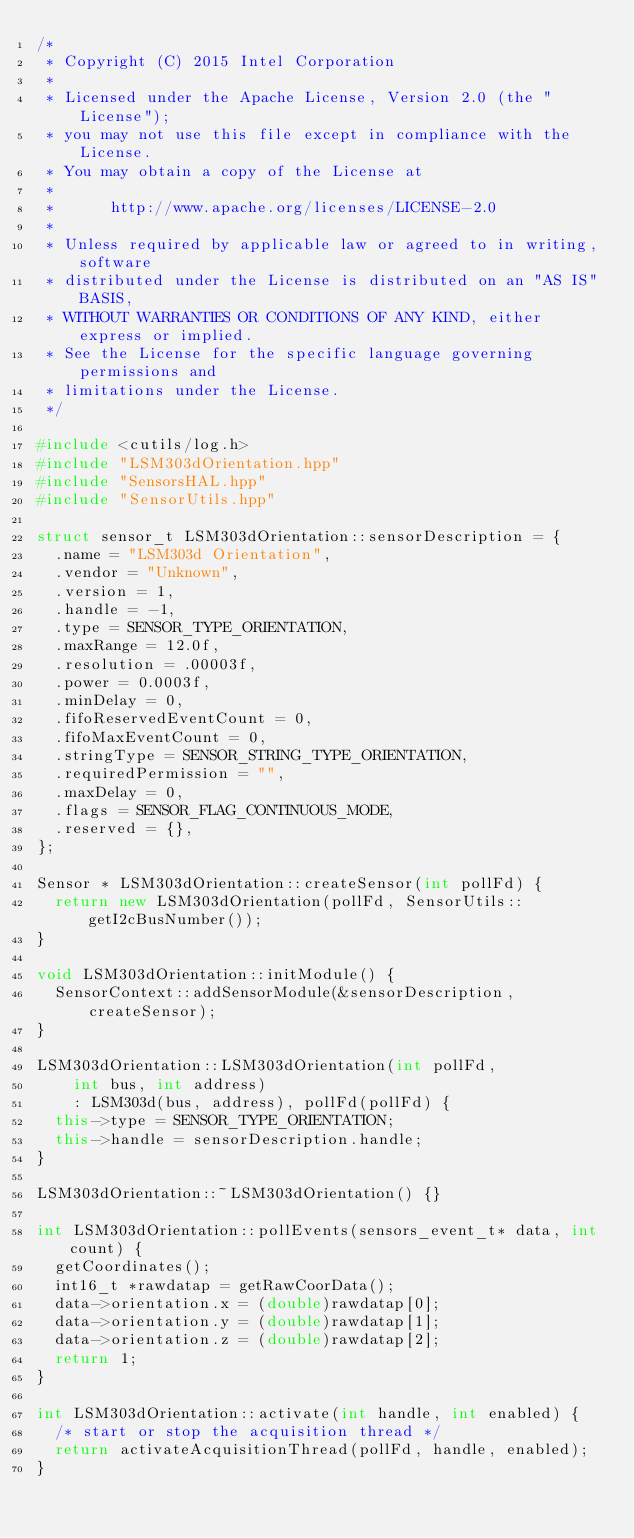<code> <loc_0><loc_0><loc_500><loc_500><_C++_>/*
 * Copyright (C) 2015 Intel Corporation
 *
 * Licensed under the Apache License, Version 2.0 (the "License");
 * you may not use this file except in compliance with the License.
 * You may obtain a copy of the License at
 *
 *      http://www.apache.org/licenses/LICENSE-2.0
 *
 * Unless required by applicable law or agreed to in writing, software
 * distributed under the License is distributed on an "AS IS" BASIS,
 * WITHOUT WARRANTIES OR CONDITIONS OF ANY KIND, either express or implied.
 * See the License for the specific language governing permissions and
 * limitations under the License.
 */

#include <cutils/log.h>
#include "LSM303dOrientation.hpp"
#include "SensorsHAL.hpp"
#include "SensorUtils.hpp"

struct sensor_t LSM303dOrientation::sensorDescription = {
  .name = "LSM303d Orientation",
  .vendor = "Unknown",
  .version = 1,
  .handle = -1,
  .type = SENSOR_TYPE_ORIENTATION,
  .maxRange = 12.0f,
  .resolution = .00003f,
  .power = 0.0003f,
  .minDelay = 0,
  .fifoReservedEventCount = 0,
  .fifoMaxEventCount = 0,
  .stringType = SENSOR_STRING_TYPE_ORIENTATION,
  .requiredPermission = "",
  .maxDelay = 0,
  .flags = SENSOR_FLAG_CONTINUOUS_MODE,
  .reserved = {},
};

Sensor * LSM303dOrientation::createSensor(int pollFd) {
  return new LSM303dOrientation(pollFd, SensorUtils::getI2cBusNumber());
}

void LSM303dOrientation::initModule() {
  SensorContext::addSensorModule(&sensorDescription, createSensor);
}

LSM303dOrientation::LSM303dOrientation(int pollFd,
    int bus, int address)
    : LSM303d(bus, address), pollFd(pollFd) {
  this->type = SENSOR_TYPE_ORIENTATION;
  this->handle = sensorDescription.handle;
}

LSM303dOrientation::~LSM303dOrientation() {}

int LSM303dOrientation::pollEvents(sensors_event_t* data, int count) {
  getCoordinates();
  int16_t *rawdatap = getRawCoorData();
  data->orientation.x = (double)rawdatap[0];
  data->orientation.y = (double)rawdatap[1];
  data->orientation.z = (double)rawdatap[2];
  return 1;
}

int LSM303dOrientation::activate(int handle, int enabled) {
  /* start or stop the acquisition thread */
  return activateAcquisitionThread(pollFd, handle, enabled);
}
</code> 